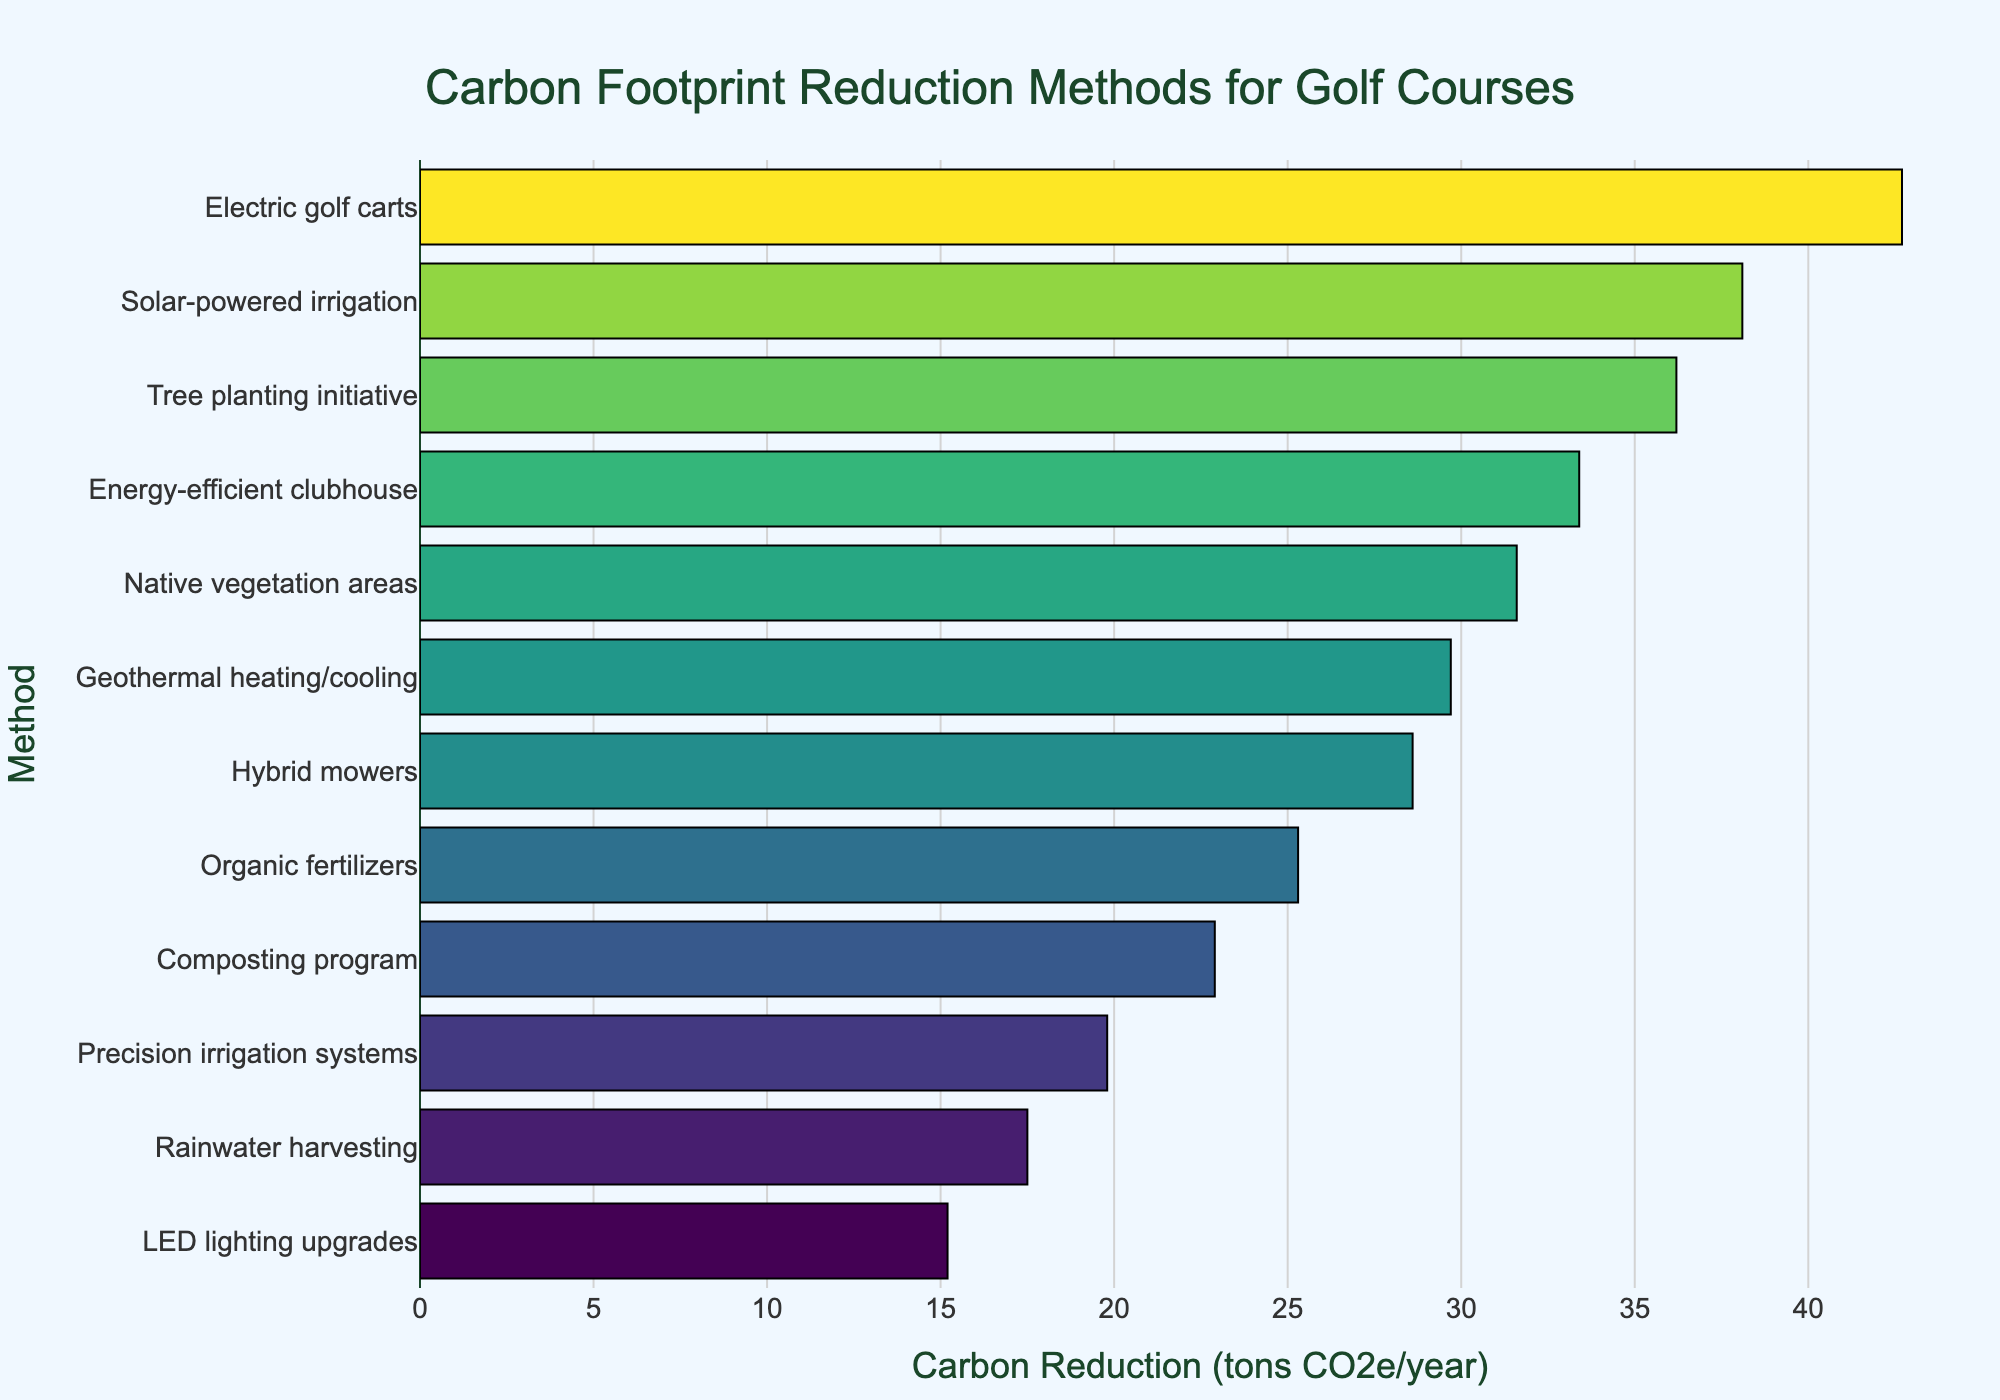Which method has the highest carbon reduction? According to the bar chart, the method with the highest carbon reduction is the one with the longest bar.
Answer: Electric golf carts Which method has the lowest carbon reduction? The method with the lowest carbon reduction is represented by the shortest bar on the chart.
Answer: LED lighting upgrades What is the combined carbon reduction of Organic fertilizers, Composting program, and Energy-efficient clubhouse? Sum the carbon reductions of Organic fertilizers (25.3), Composting program (22.9), and Energy-efficient clubhouse (33.4). The total is 25.3 + 22.9 + 33.4.
Answer: 81.6 tons CO2e/year Is the carbon reduction of Solar-powered irrigation greater than that of Hybrid mowers? Compare the lengths of the bars for Solar-powered irrigation (38.1) and Hybrid mowers (28.6).
Answer: Yes How much more carbon reduction does Rainwater harvesting achieve compared to Precision irrigation systems? Subtract the carbon reduction value of Precision irrigation systems (19.8) from Rainwater harvesting (17.5). The difference is 19.8 - 17.5.
Answer: 2.3 tons CO2e/year What is the median carbon reduction value among all methods shown? List all the carbon reduction values and find the middle one. The sorted values are 15.2, 17.5, 19.8, 22.9, 25.3, 28.6, 29.7, 31.6, 33.4, 36.2, 38.1, 42.7. The median is the average of 28.6 and 29.7.
Answer: 29.15 tons CO2e/year How does the carbon reduction of Native vegetation areas compare to that of Geothermal heating/cooling? Compare the two bars for Native vegetation areas (31.6) and Geothermal heating/cooling (29.7) to see which is longer.
Answer: Native vegetation areas have higher reduction Which methods show a carbon reduction between 20 and 30 tons CO2e/year? Identify bars with lengths corresponding to the specified range: Organic fertilizers, Composting program, Hybrid mowers, Geothermal heating/cooling.
Answer: Organic fertilizers, Composting program, Hybrid mowers, Geothermal heating/cooling 